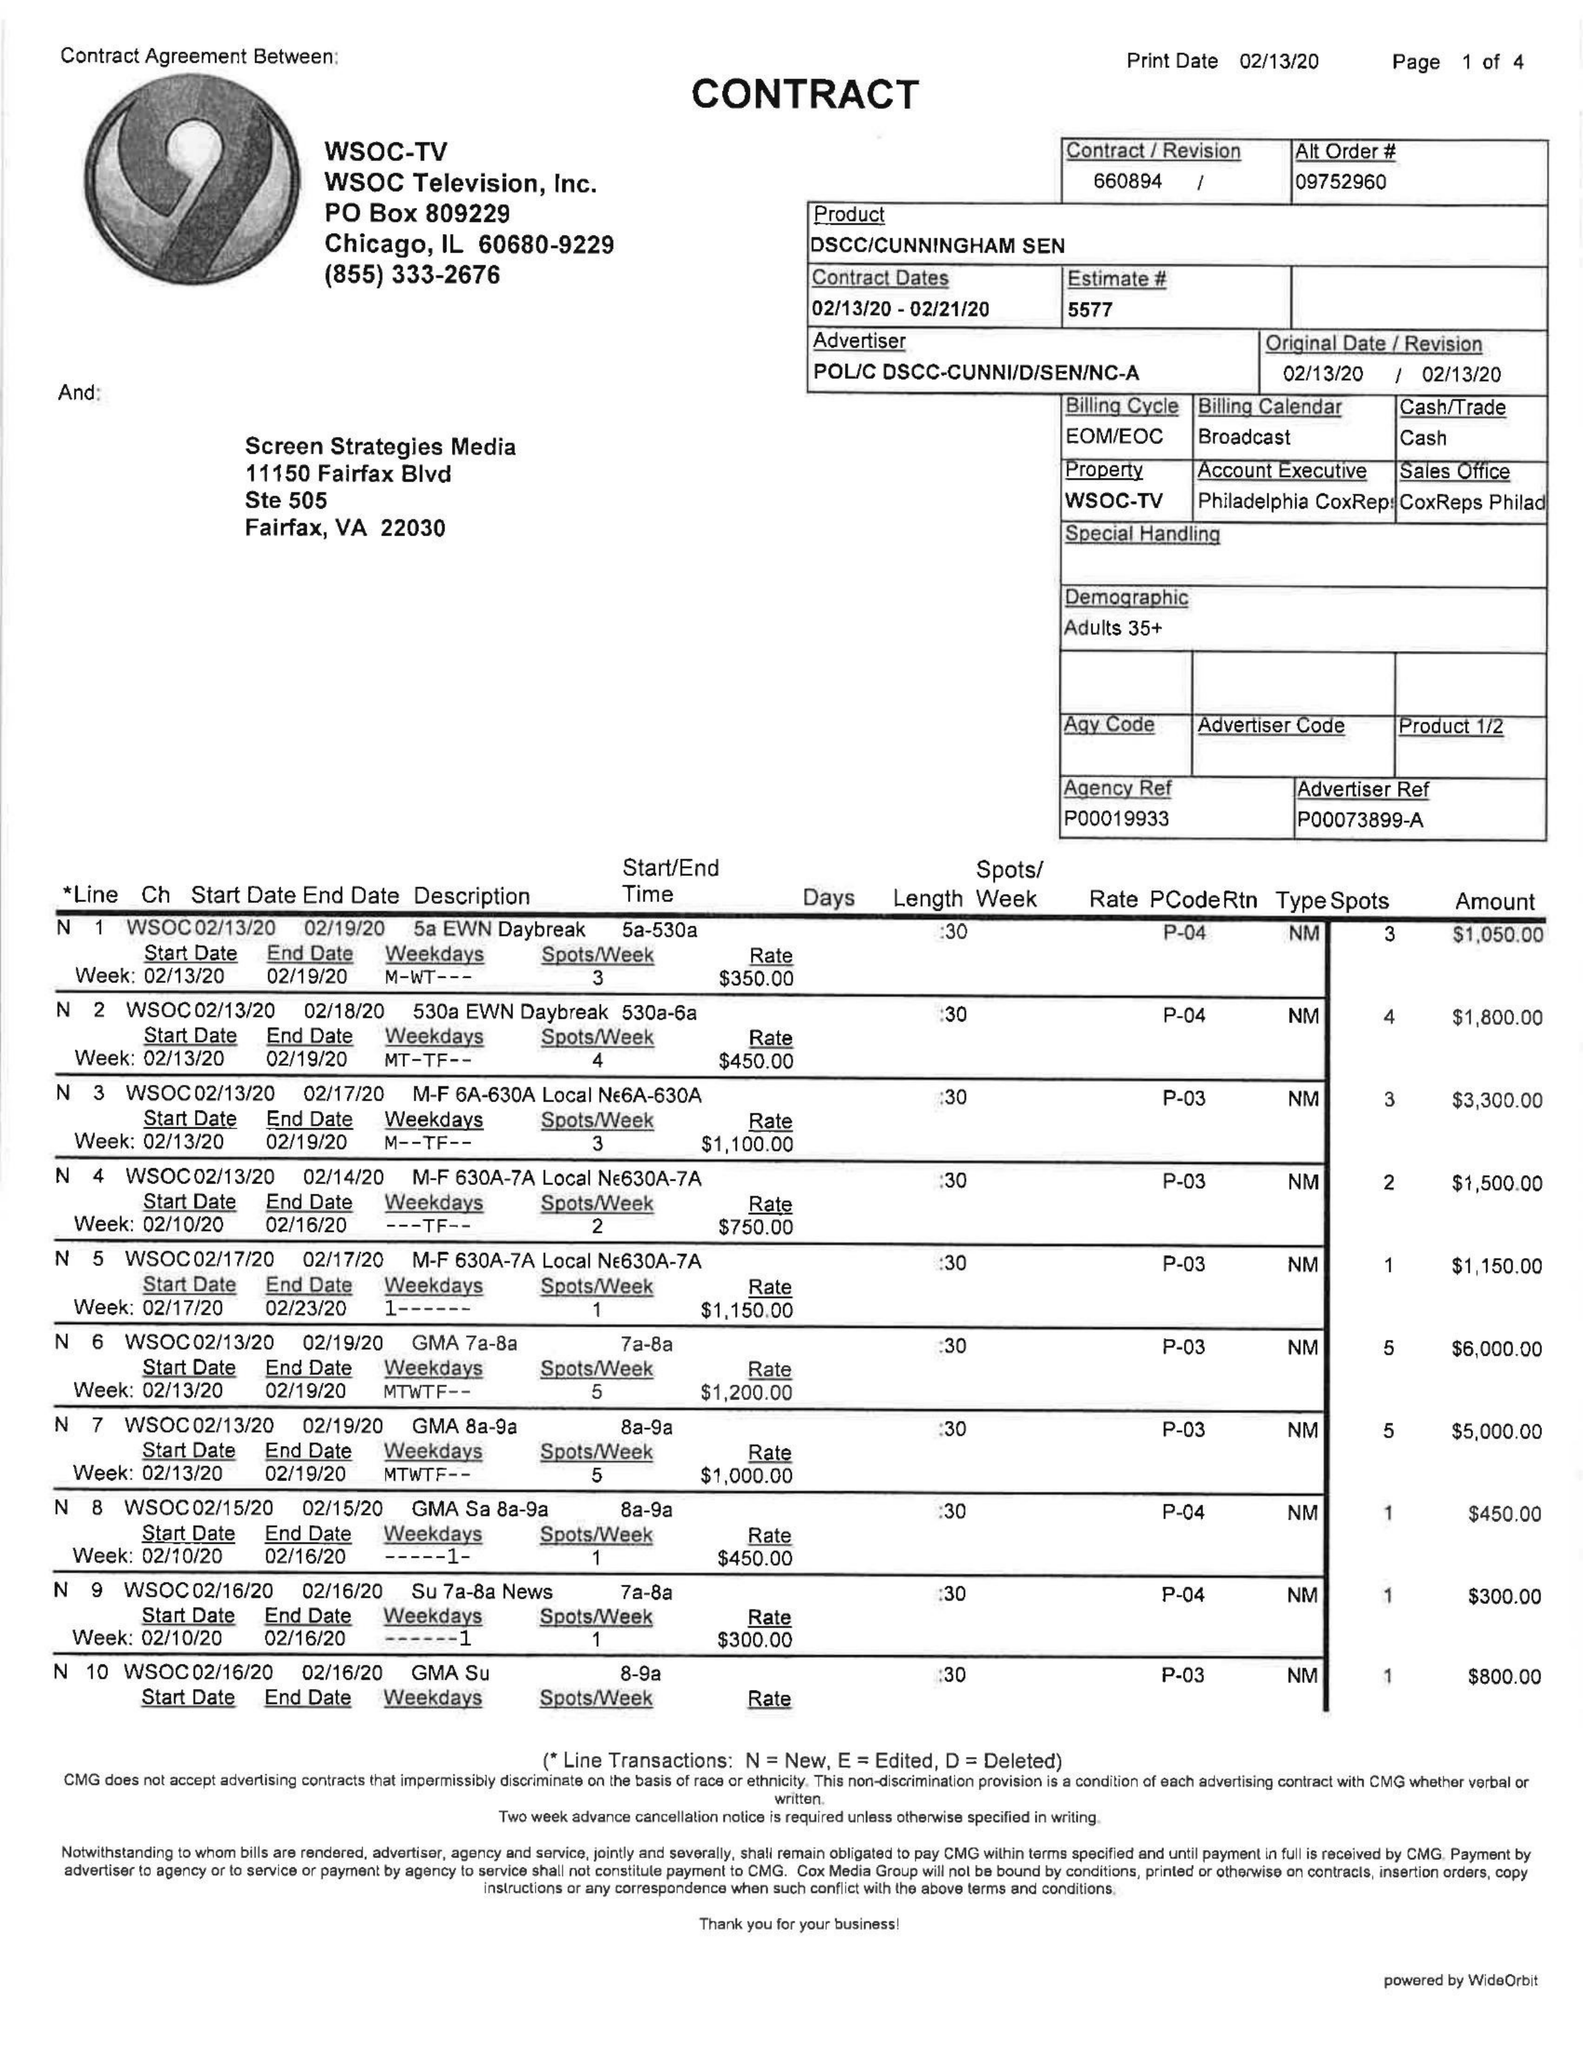What is the value for the flight_from?
Answer the question using a single word or phrase. 02/13/20 